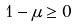<formula> <loc_0><loc_0><loc_500><loc_500>1 - \mu \geq 0</formula> 